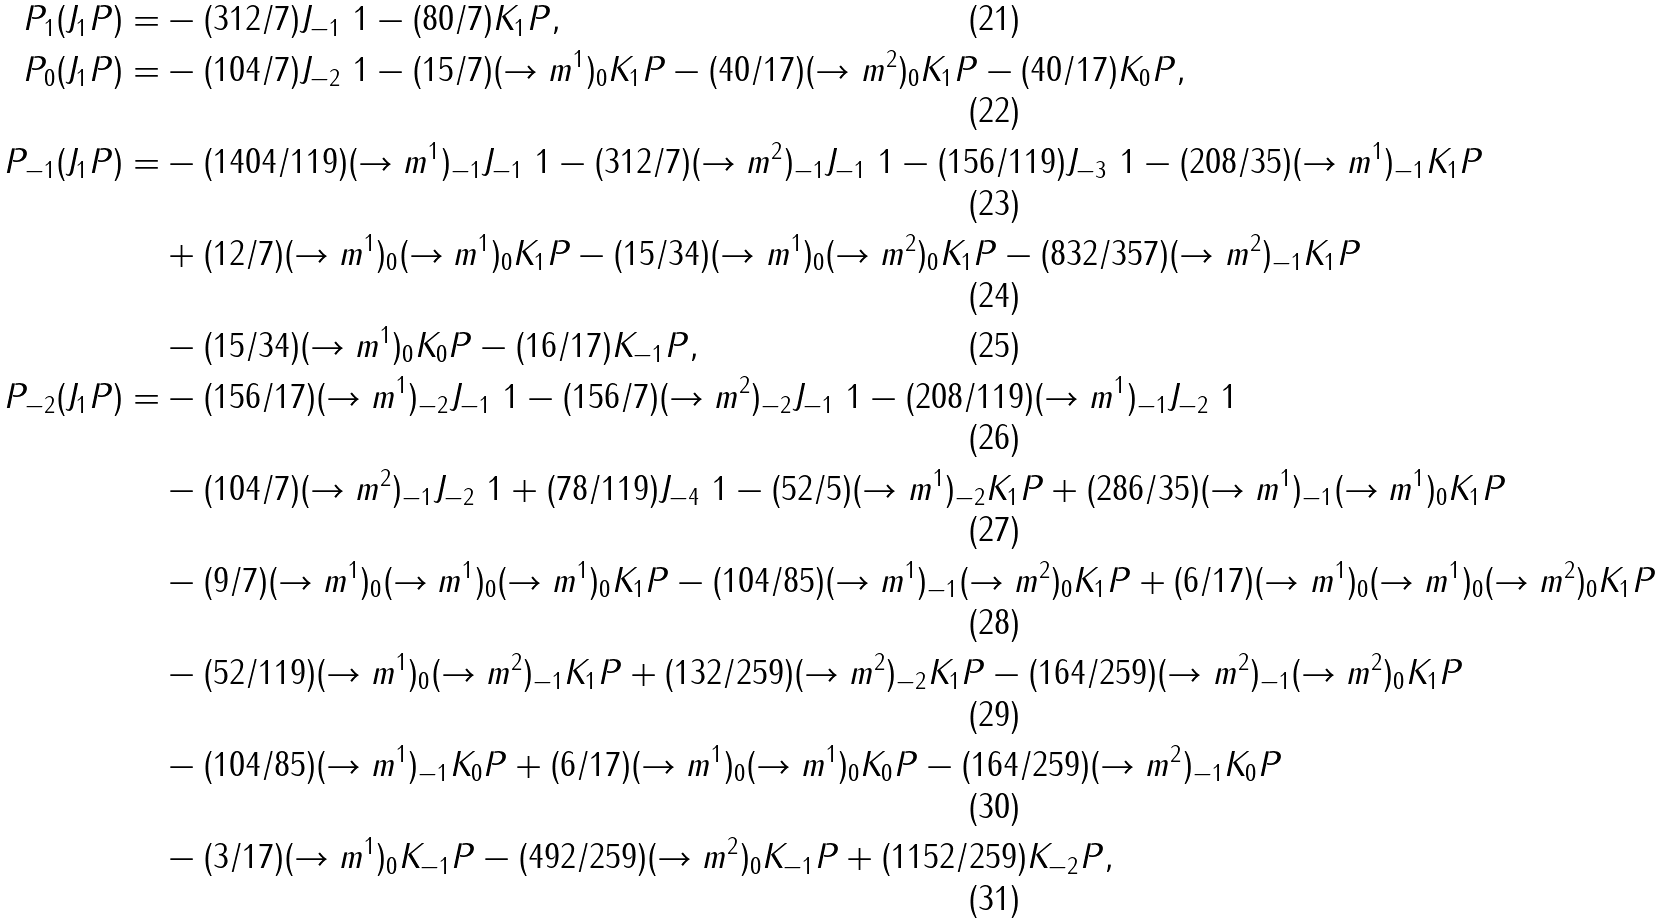Convert formula to latex. <formula><loc_0><loc_0><loc_500><loc_500>P _ { 1 } ( J _ { 1 } P ) = & - ( 3 1 2 / 7 ) J _ { - 1 } \ 1 - ( 8 0 / 7 ) K _ { 1 } P , \\ P _ { 0 } ( J _ { 1 } P ) = & - ( 1 0 4 / 7 ) J _ { - 2 } \ 1 - ( 1 5 / 7 ) ( \to m ^ { 1 } ) _ { 0 } K _ { 1 } P - ( 4 0 / 1 7 ) ( \to m ^ { 2 } ) _ { 0 } K _ { 1 } P - ( 4 0 / 1 7 ) K _ { 0 } P , \\ P _ { - 1 } ( J _ { 1 } P ) = & - ( 1 4 0 4 / 1 1 9 ) ( \to m ^ { 1 } ) _ { - 1 } J _ { - 1 } \ 1 - ( 3 1 2 / 7 ) ( \to m ^ { 2 } ) _ { - 1 } J _ { - 1 } \ 1 - ( 1 5 6 / 1 1 9 ) J _ { - 3 } \ 1 - ( 2 0 8 / 3 5 ) ( \to m ^ { 1 } ) _ { - 1 } K _ { 1 } P \\ & + ( 1 2 / 7 ) ( \to m ^ { 1 } ) _ { 0 } ( \to m ^ { 1 } ) _ { 0 } K _ { 1 } P - ( 1 5 / 3 4 ) ( \to m ^ { 1 } ) _ { 0 } ( \to m ^ { 2 } ) _ { 0 } K _ { 1 } P - ( 8 3 2 / 3 5 7 ) ( \to m ^ { 2 } ) _ { - 1 } K _ { 1 } P \\ & - ( 1 5 / 3 4 ) ( \to m ^ { 1 } ) _ { 0 } K _ { 0 } P - ( 1 6 / 1 7 ) K _ { - 1 } P , \\ P _ { - 2 } ( J _ { 1 } P ) = & - ( 1 5 6 / 1 7 ) ( \to m ^ { 1 } ) _ { - 2 } J _ { - 1 } \ 1 - ( 1 5 6 / 7 ) ( \to m ^ { 2 } ) _ { - 2 } J _ { - 1 } \ 1 - ( 2 0 8 / 1 1 9 ) ( \to m ^ { 1 } ) _ { - 1 } J _ { - 2 } \ 1 \\ & - ( 1 0 4 / 7 ) ( \to m ^ { 2 } ) _ { - 1 } J _ { - 2 } \ 1 + ( 7 8 / 1 1 9 ) J _ { - 4 } \ 1 - ( 5 2 / 5 ) ( \to m ^ { 1 } ) _ { - 2 } K _ { 1 } P + ( 2 8 6 / 3 5 ) ( \to m ^ { 1 } ) _ { - 1 } ( \to m ^ { 1 } ) _ { 0 } K _ { 1 } P \\ & - ( 9 / 7 ) ( \to m ^ { 1 } ) _ { 0 } ( \to m ^ { 1 } ) _ { 0 } ( \to m ^ { 1 } ) _ { 0 } K _ { 1 } P - ( 1 0 4 / 8 5 ) ( \to m ^ { 1 } ) _ { - 1 } ( \to m ^ { 2 } ) _ { 0 } K _ { 1 } P + ( 6 / 1 7 ) ( \to m ^ { 1 } ) _ { 0 } ( \to m ^ { 1 } ) _ { 0 } ( \to m ^ { 2 } ) _ { 0 } K _ { 1 } P \\ & - ( 5 2 / 1 1 9 ) ( \to m ^ { 1 } ) _ { 0 } ( \to m ^ { 2 } ) _ { - 1 } K _ { 1 } P + ( 1 3 2 / 2 5 9 ) ( \to m ^ { 2 } ) _ { - 2 } K _ { 1 } P - ( 1 6 4 / 2 5 9 ) ( \to m ^ { 2 } ) _ { - 1 } ( \to m ^ { 2 } ) _ { 0 } K _ { 1 } P \\ & - ( 1 0 4 / 8 5 ) ( \to m ^ { 1 } ) _ { - 1 } K _ { 0 } P + ( 6 / 1 7 ) ( \to m ^ { 1 } ) _ { 0 } ( \to m ^ { 1 } ) _ { 0 } K _ { 0 } P - ( 1 6 4 / 2 5 9 ) ( \to m ^ { 2 } ) _ { - 1 } K _ { 0 } P \\ & - ( 3 / 1 7 ) ( \to m ^ { 1 } ) _ { 0 } K _ { - 1 } P - ( 4 9 2 / 2 5 9 ) ( \to m ^ { 2 } ) _ { 0 } K _ { - 1 } P + ( 1 1 5 2 / 2 5 9 ) K _ { - 2 } P ,</formula> 